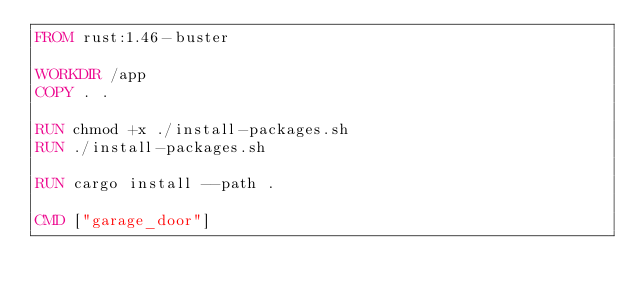Convert code to text. <code><loc_0><loc_0><loc_500><loc_500><_Dockerfile_>FROM rust:1.46-buster

WORKDIR /app
COPY . .

RUN chmod +x ./install-packages.sh
RUN ./install-packages.sh

RUN cargo install --path .

CMD ["garage_door"]

</code> 